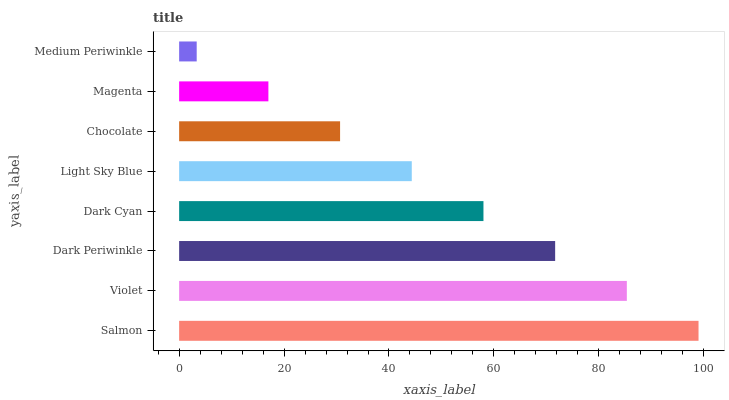Is Medium Periwinkle the minimum?
Answer yes or no. Yes. Is Salmon the maximum?
Answer yes or no. Yes. Is Violet the minimum?
Answer yes or no. No. Is Violet the maximum?
Answer yes or no. No. Is Salmon greater than Violet?
Answer yes or no. Yes. Is Violet less than Salmon?
Answer yes or no. Yes. Is Violet greater than Salmon?
Answer yes or no. No. Is Salmon less than Violet?
Answer yes or no. No. Is Dark Cyan the high median?
Answer yes or no. Yes. Is Light Sky Blue the low median?
Answer yes or no. Yes. Is Light Sky Blue the high median?
Answer yes or no. No. Is Magenta the low median?
Answer yes or no. No. 